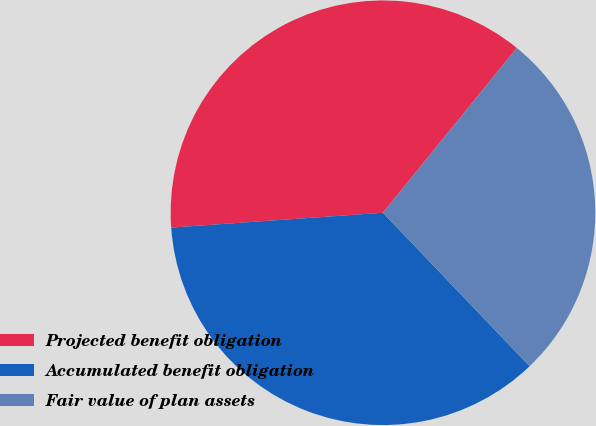<chart> <loc_0><loc_0><loc_500><loc_500><pie_chart><fcel>Projected benefit obligation<fcel>Accumulated benefit obligation<fcel>Fair value of plan assets<nl><fcel>36.97%<fcel>36.02%<fcel>27.01%<nl></chart> 